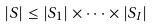<formula> <loc_0><loc_0><loc_500><loc_500>| S | \leq | S _ { 1 } | \times \cdots \times | S _ { I } |</formula> 